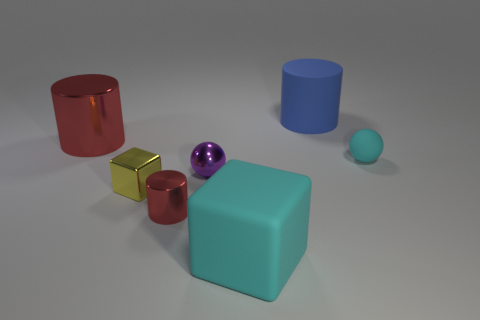Subtract all big cylinders. How many cylinders are left? 1 Subtract all purple balls. How many red cylinders are left? 2 Add 1 tiny yellow objects. How many objects exist? 8 Subtract 0 brown spheres. How many objects are left? 7 Subtract all blocks. How many objects are left? 5 Subtract all small things. Subtract all tiny blocks. How many objects are left? 2 Add 3 small red metal things. How many small red metal things are left? 4 Add 3 tiny yellow spheres. How many tiny yellow spheres exist? 3 